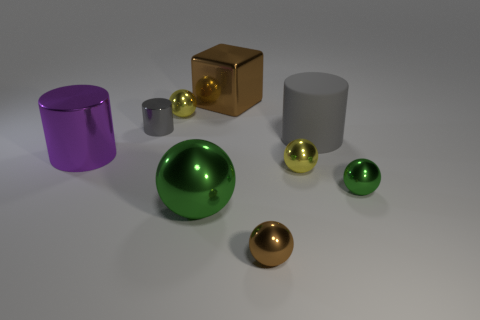Subtract all big metal balls. How many balls are left? 4 Subtract all blue spheres. Subtract all cyan cylinders. How many spheres are left? 5 Subtract all cylinders. How many objects are left? 6 Subtract all gray metal cylinders. Subtract all big green objects. How many objects are left? 7 Add 1 big gray rubber things. How many big gray rubber things are left? 2 Add 1 small yellow shiny spheres. How many small yellow shiny spheres exist? 3 Subtract 0 blue balls. How many objects are left? 9 